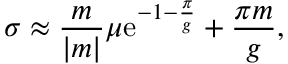Convert formula to latex. <formula><loc_0><loc_0><loc_500><loc_500>\sigma \approx { \frac { m } { | m | } } \mu e ^ { - 1 - { \frac { \pi } { g } } } + { \frac { \pi m } { g } } ,</formula> 